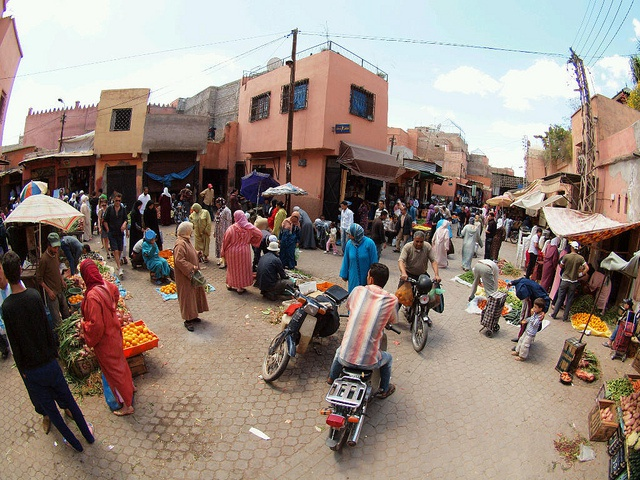Describe the objects in this image and their specific colors. I can see people in tan, black, maroon, and gray tones, people in tan, black, darkgray, lightpink, and gray tones, people in tan, brown, maroon, and salmon tones, motorcycle in tan, black, gray, and darkgray tones, and motorcycle in tan, black, gray, darkgray, and lightgray tones in this image. 